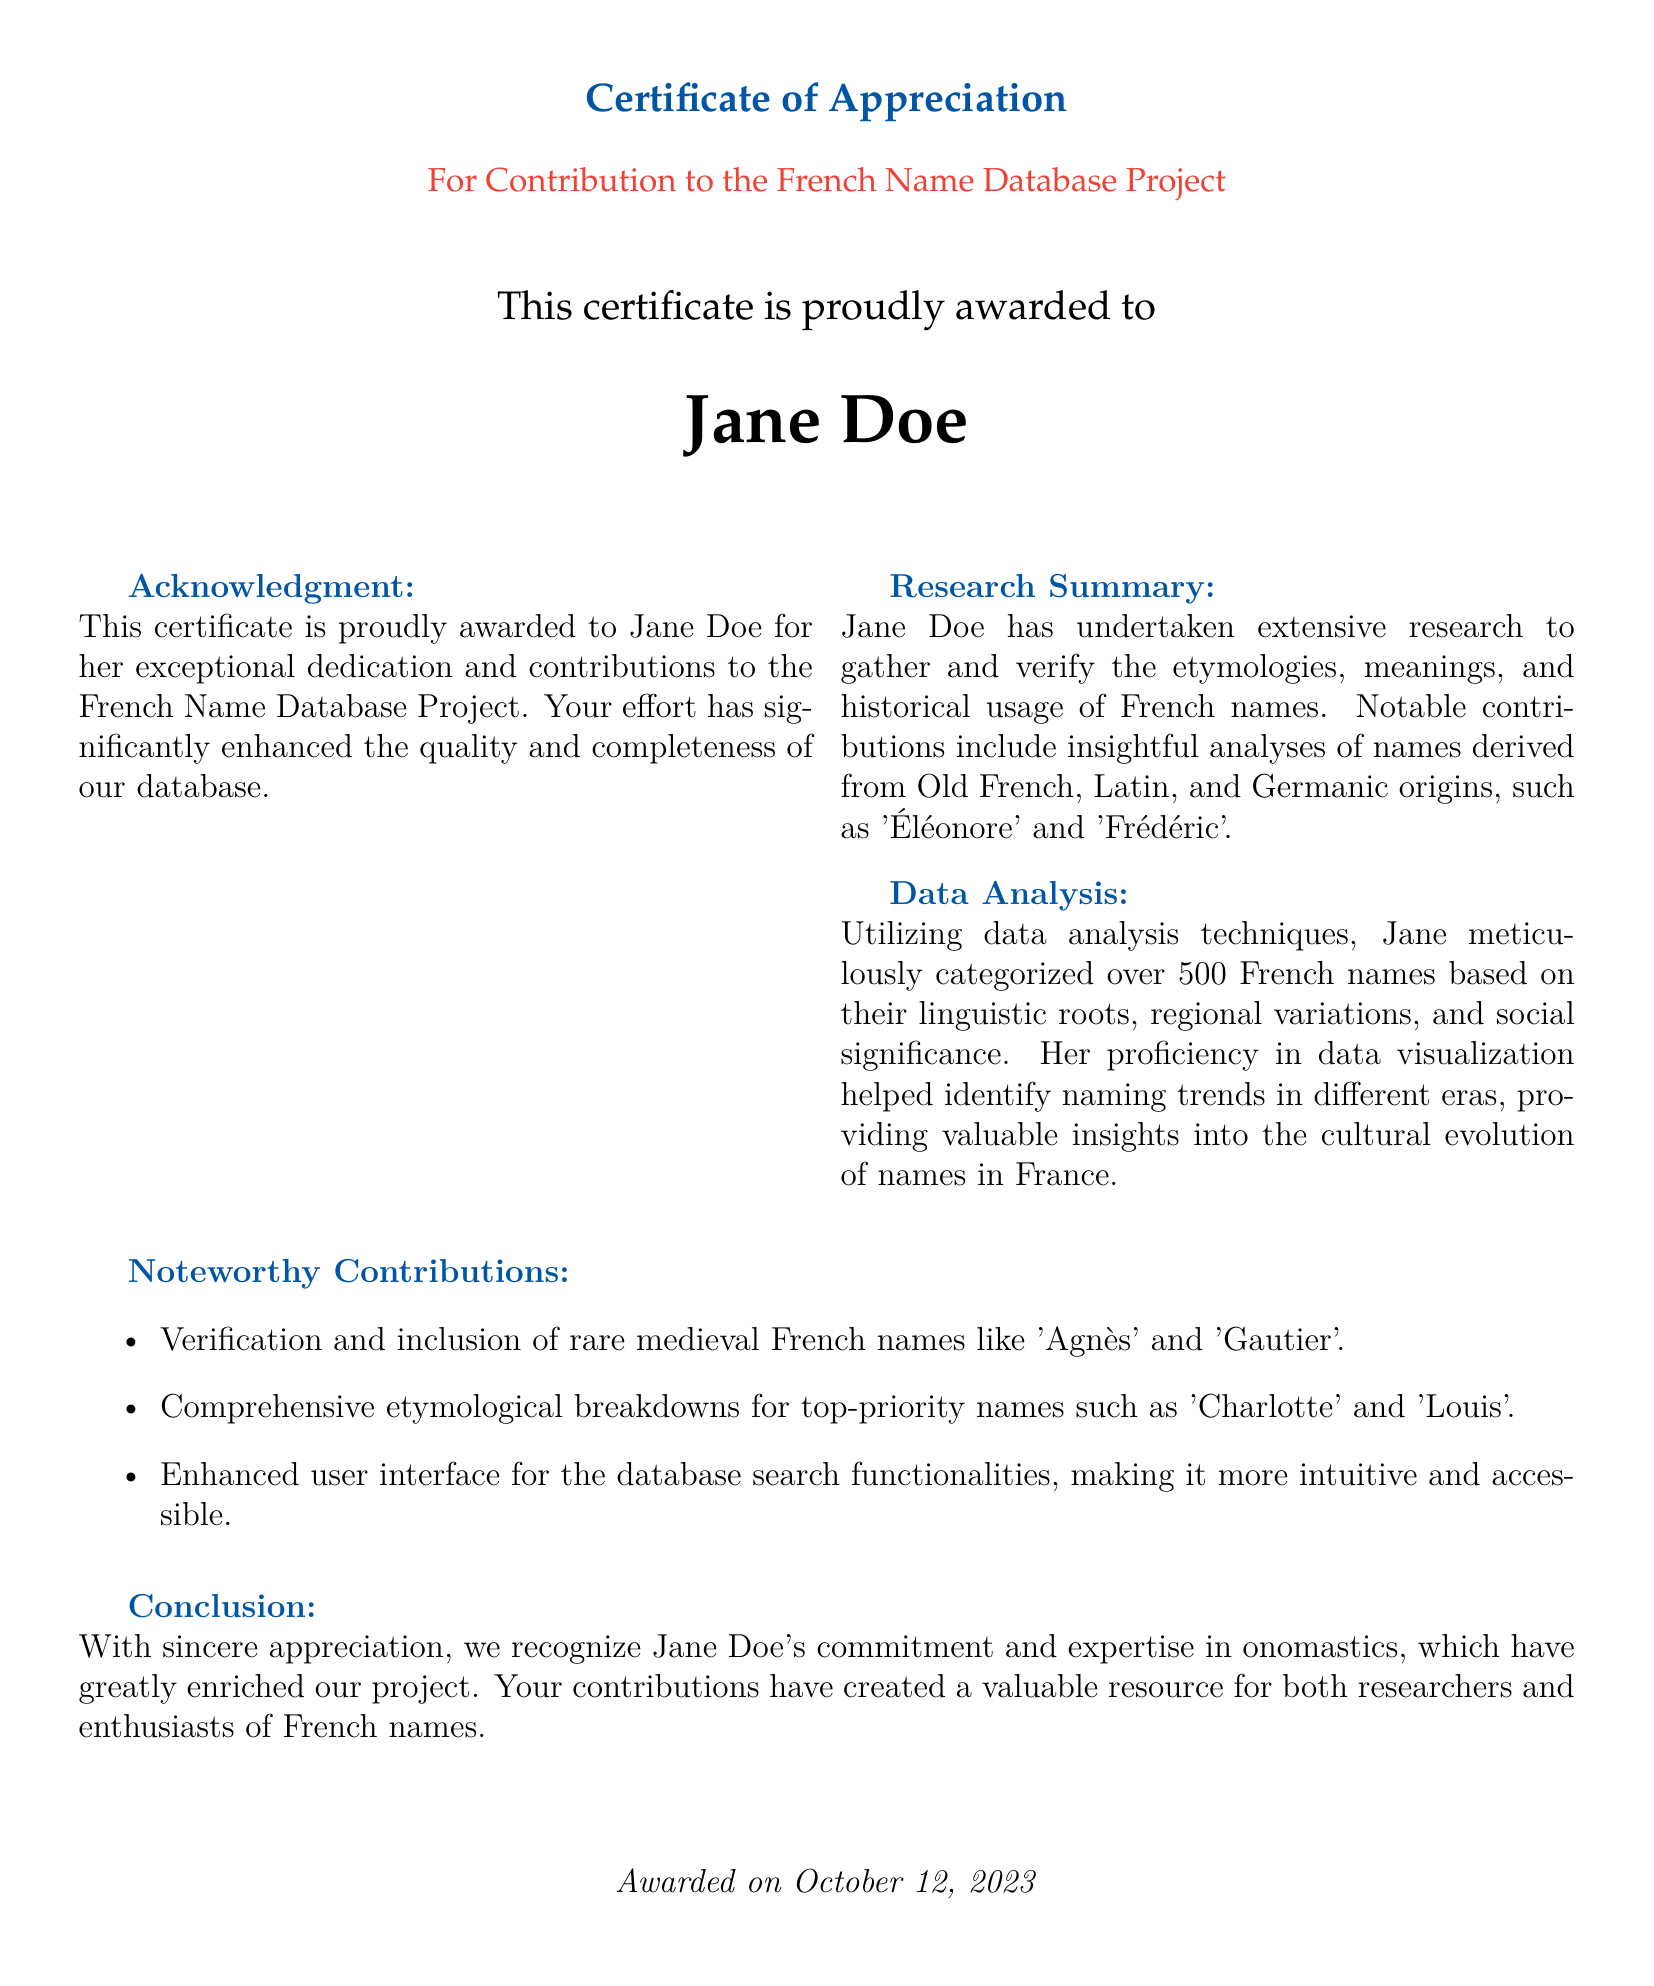What is the name of the award recipient? The award recipient's name is specifically mentioned in the document, which is Jane Doe.
Answer: Jane Doe What project is this certificate for? The document specifies that the certificate is for contribution to a particular project named the French Name Database Project.
Answer: French Name Database Project When was the certificate awarded? The date of the award is explicitly stated in the document as October 12, 2023.
Answer: October 12, 2023 What is one language of origin for names analyzed in the project? The document lists Old French, Latin, and Germanic as the origins of the names researched, making it clear the project involved multiple languages.
Answer: Old French How many French names did Jane categorize? The document indicates that Jane categorized over 500 French names, providing a concrete number of names involved in her work.
Answer: 500 What type of contributions did Jane make to the database's user interface? The document notes that Jane enhanced the user interface for the database's search functionalities, indicating her involvement in improving user interaction.
Answer: Enhanced user interface What is one of the notable names included in Jane's research? The document mentions notable contributions, including the analysis of names like 'Éléonore' and 'Frédéric', specifying names from her research.
Answer: Éléonore What is the main focus of the Certificate of Appreciation? The document explicitly states the main focus is on recognizing Jane Doe's dedication and contributions to the French Name Database Project.
Answer: Dedication and contributions 